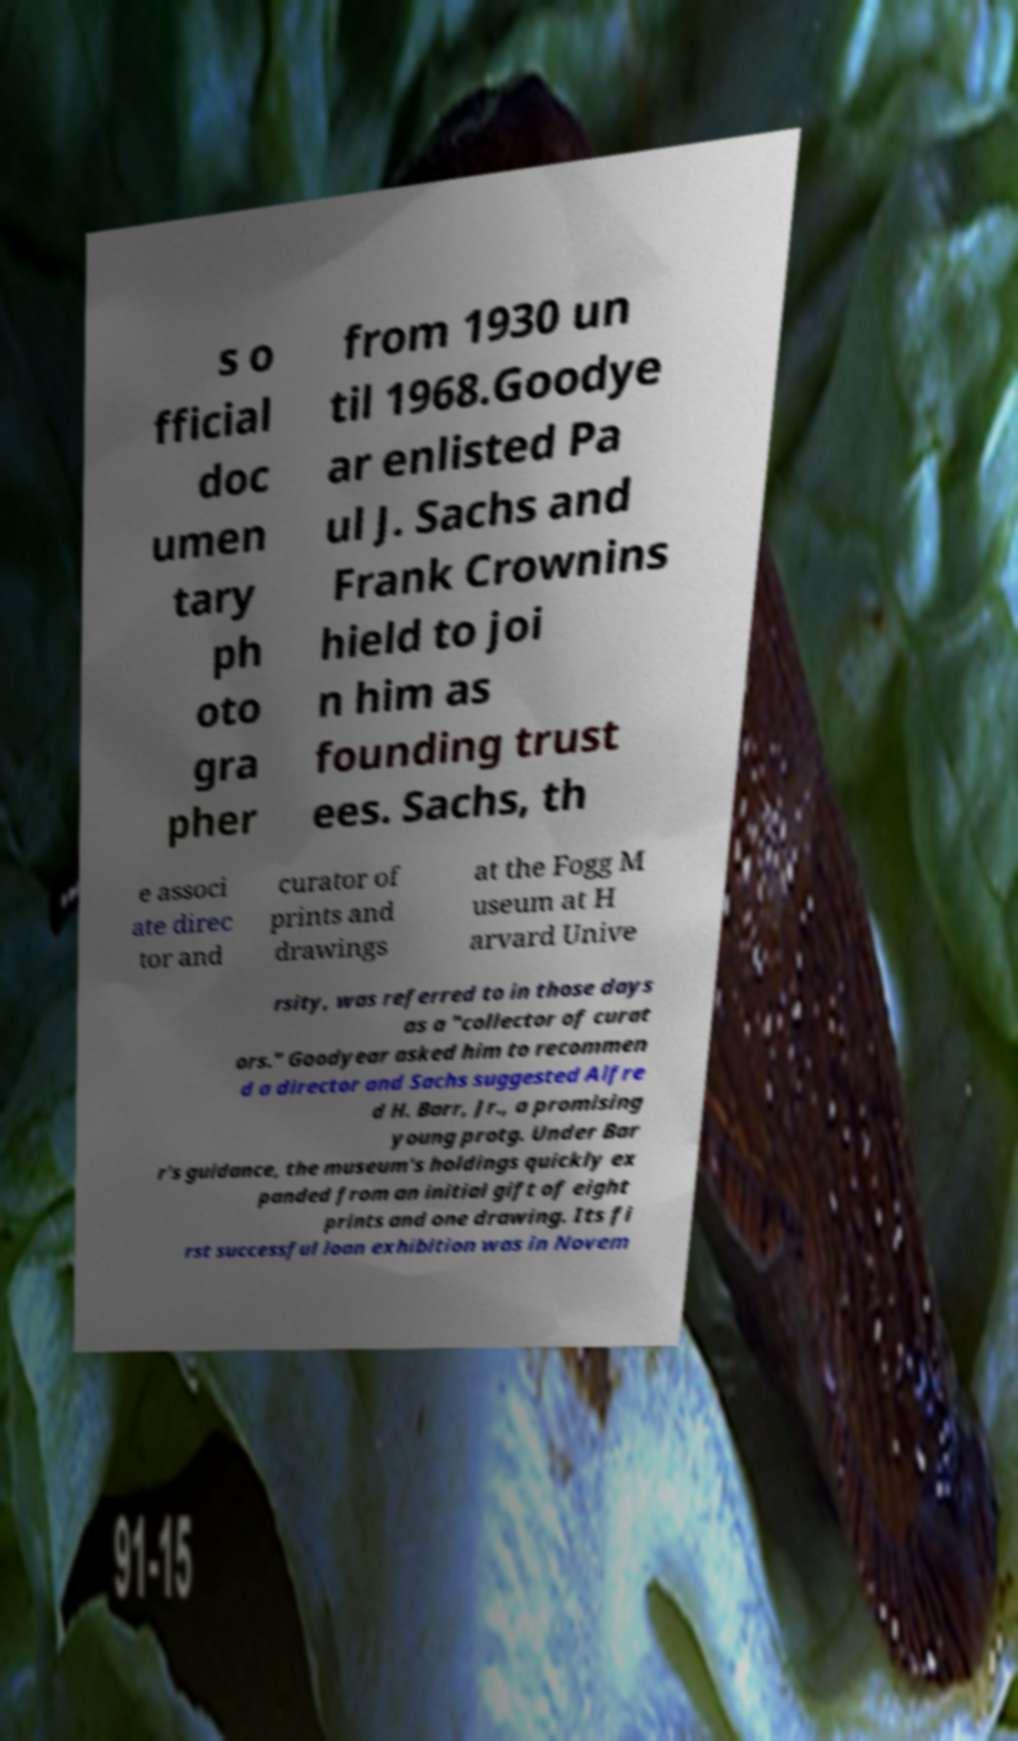I need the written content from this picture converted into text. Can you do that? s o fficial doc umen tary ph oto gra pher from 1930 un til 1968.Goodye ar enlisted Pa ul J. Sachs and Frank Crownins hield to joi n him as founding trust ees. Sachs, th e associ ate direc tor and curator of prints and drawings at the Fogg M useum at H arvard Unive rsity, was referred to in those days as a "collector of curat ors." Goodyear asked him to recommen d a director and Sachs suggested Alfre d H. Barr, Jr., a promising young protg. Under Bar r's guidance, the museum's holdings quickly ex panded from an initial gift of eight prints and one drawing. Its fi rst successful loan exhibition was in Novem 